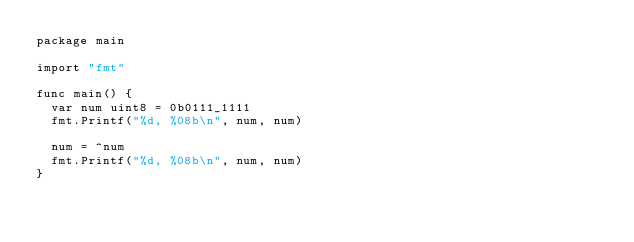Convert code to text. <code><loc_0><loc_0><loc_500><loc_500><_Go_>package main

import "fmt"

func main() {
	var num uint8 = 0b0111_1111
	fmt.Printf("%d, %08b\n", num, num)

	num = ^num
	fmt.Printf("%d, %08b\n", num, num)
}
</code> 